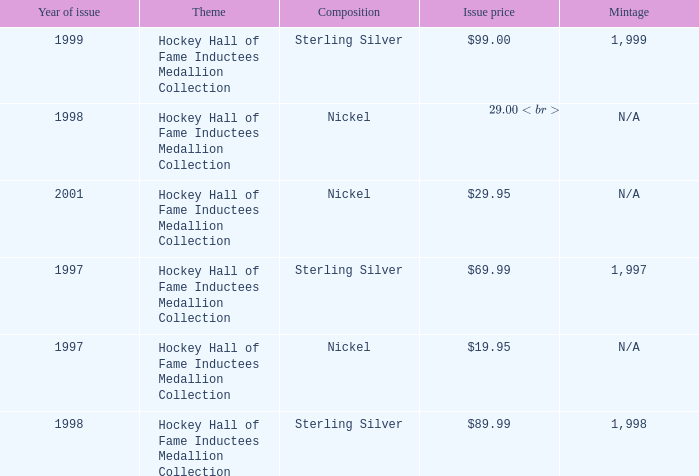Which composition has an issue price of $99.00? Sterling Silver. 